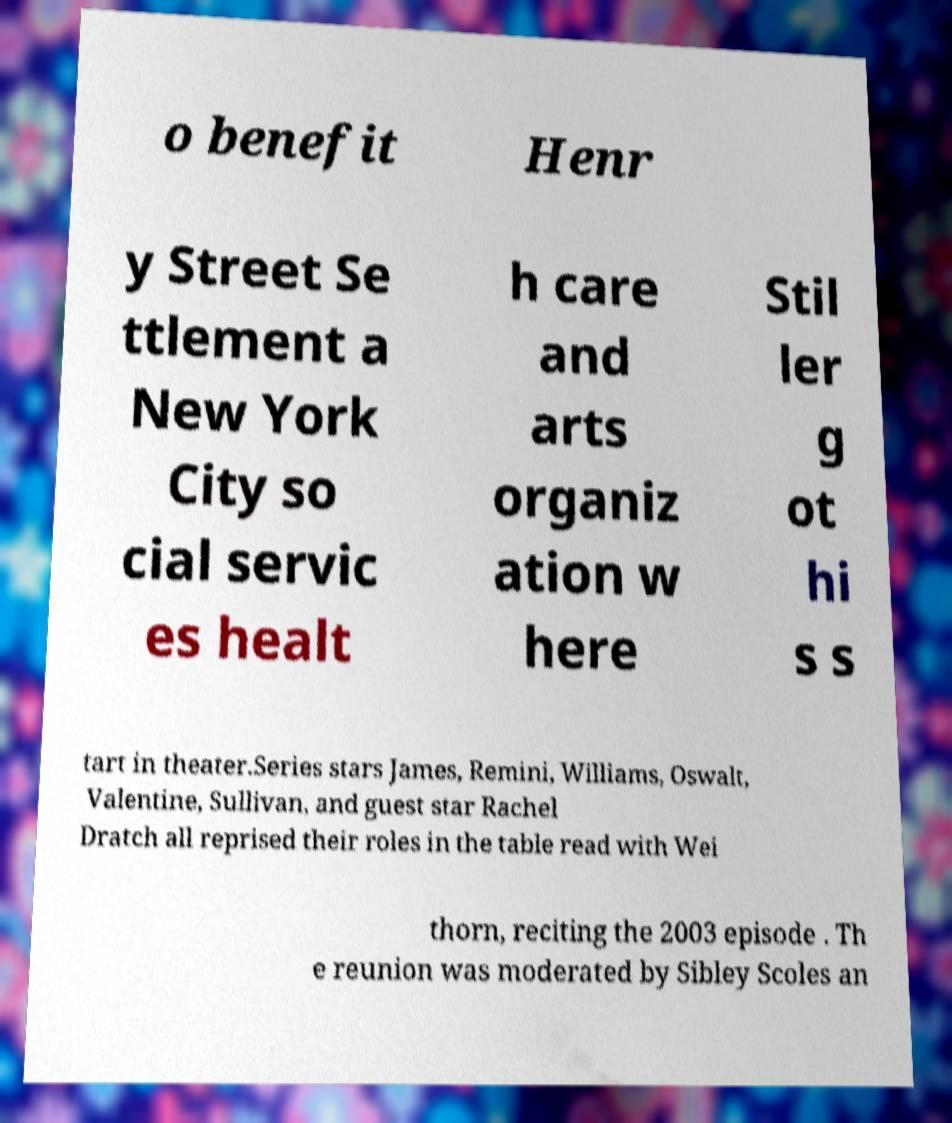There's text embedded in this image that I need extracted. Can you transcribe it verbatim? o benefit Henr y Street Se ttlement a New York City so cial servic es healt h care and arts organiz ation w here Stil ler g ot hi s s tart in theater.Series stars James, Remini, Williams, Oswalt, Valentine, Sullivan, and guest star Rachel Dratch all reprised their roles in the table read with Wei thorn, reciting the 2003 episode . Th e reunion was moderated by Sibley Scoles an 